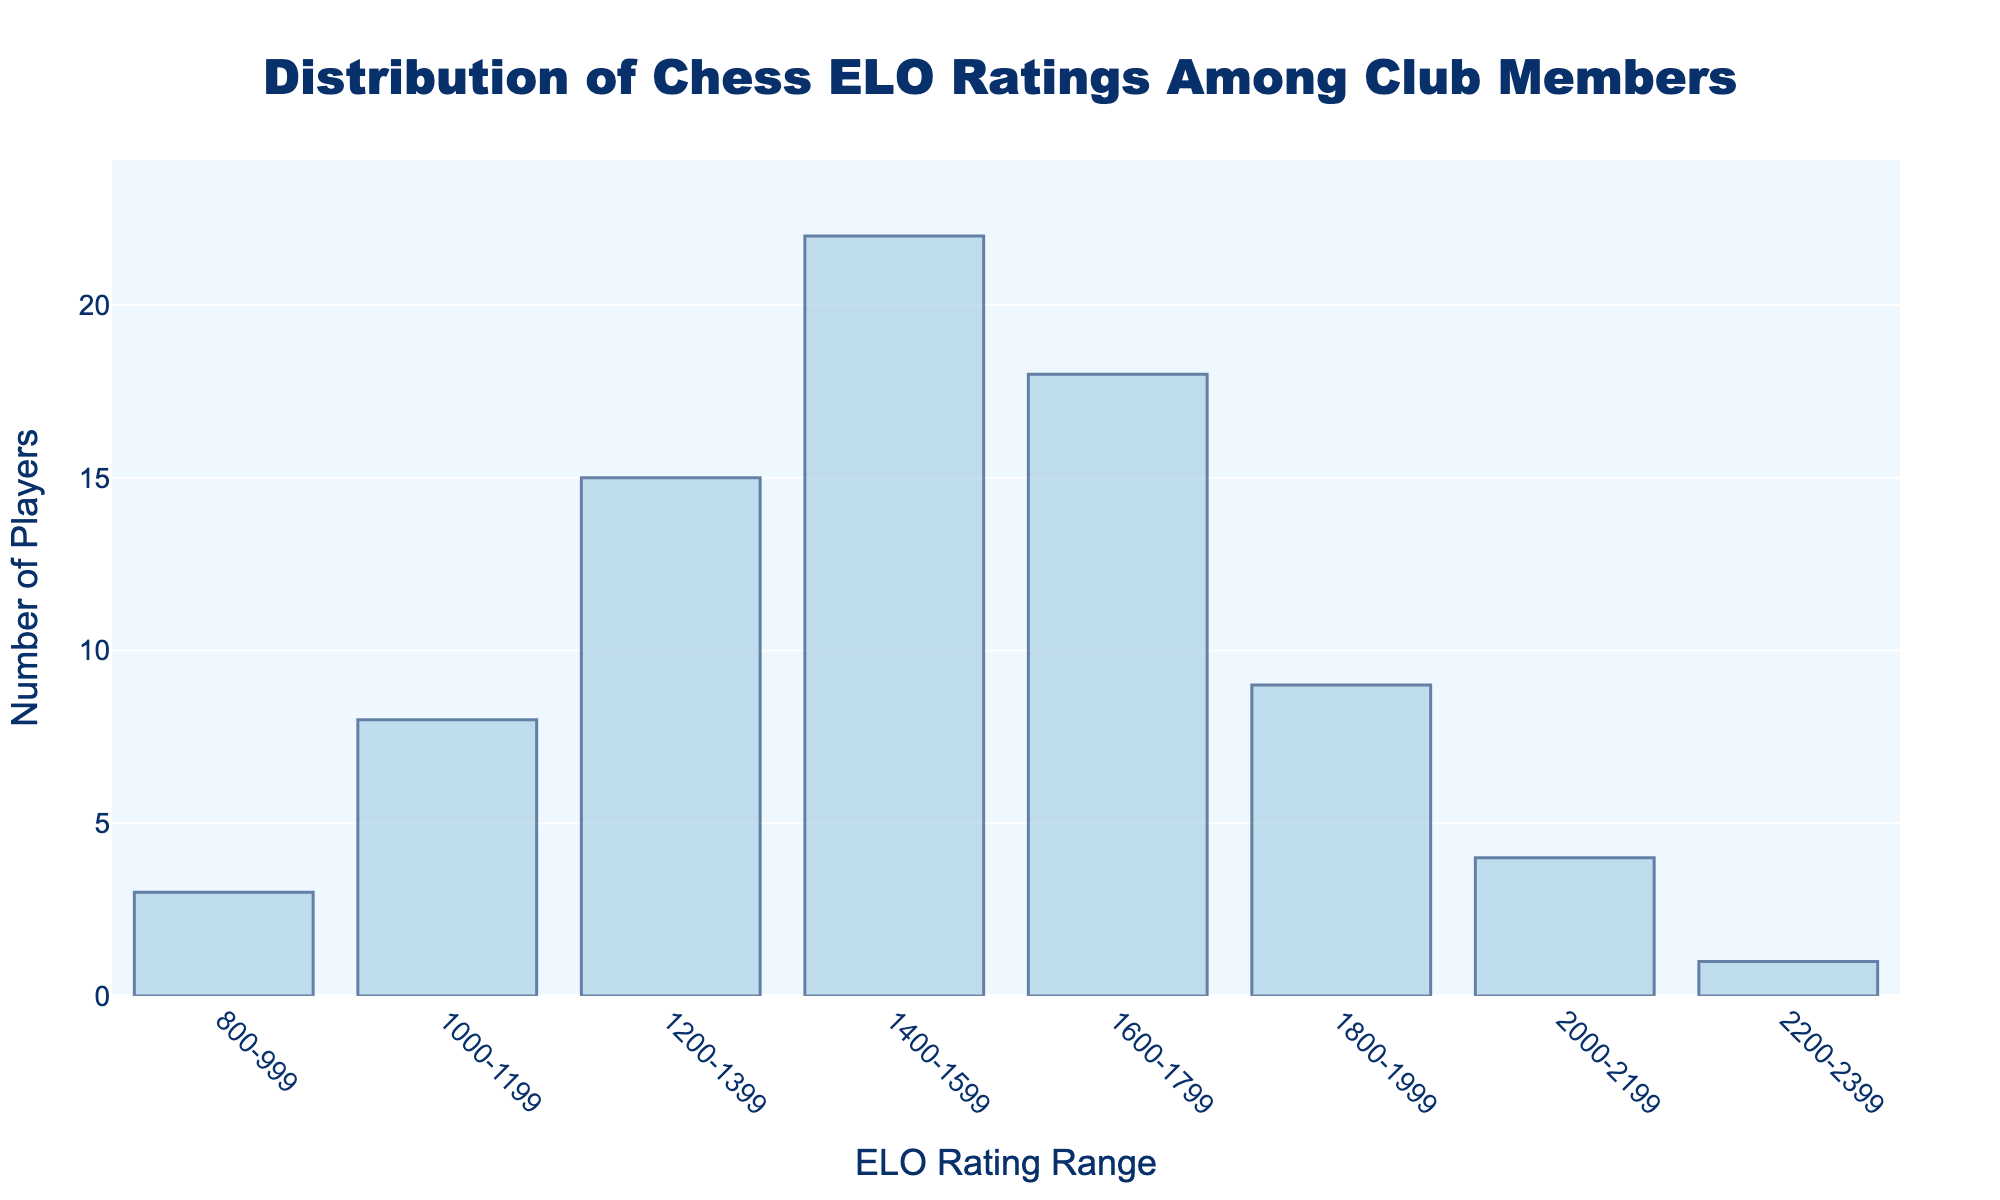What is the range of the most common ELO ratings among club members? The range with the highest frequency is identified by looking at the bar with the maximum height in the histogram. The bar representing the 1400-1599 range is the tallest, indicating it is the most common.
Answer: 1400-1599 What is the total number of players with ELO ratings less than 1400? Add the frequencies of all ranges below 1400: sum of frequencies (for 800-999, 1000-1199, 1200-1399) is 3 + 8 + 15 = 26.
Answer: 26 How many more players are there in the 1400-1599 range than in the 1600-1799 range? Subtract the frequency of the 1600-1799 range from the frequency of the 1400-1599 range: 22 - 18 = 4.
Answer: 4 Which ELO rating range has the least number of players? Look for the bar with the smallest height in the histogram. The range 2200-2399 has the smallest height, indicating the least number of players.
Answer: 2200-2399 What is the total number of players represented in the histogram? Add up all the frequencies: 3 + 8 + 15 + 22 + 18 + 9 + 4 + 1 = 80.
Answer: 80 What's the combined total of players with ELO ratings between 1600 and 1999? Add the frequencies for the ranges 1600-1799 and 1800-1999: 18 + 9 = 27.
Answer: 27 How does the number of players in the 2000-2199 range compare to the 2200-2399 range? Compare the frequencies of the two ranges: 4 (2000-2199) is greater than 1 (2200-2399).
Answer: more In which range does the frequency drop to a single digit for the first time when moving from lower to higher ELO ratings? Identify the first range where the frequency is less than 10 when moving from lower to higher ratings. This occurs in the 1800-1999 range with a frequency of 9.
Answer: 1800-1999 Which ELO rating ranges exceed a frequency of 10 players? Identify ranges with frequencies greater than 10: The ranges 1200-1399, 1400-1599, and 1600-1799 have frequencies of 15, 22, and 18 respectively.
Answer: 1200-1399, 1400-1599, 1600-1799 How wide is each bar on the x-axis, representing the ELO rating ranges? Each bar's width can be identified by the difference in the range it represents. Most bars span a difference of 200 (e.g., 1000-1199, 1200-1399).
Answer: 200 